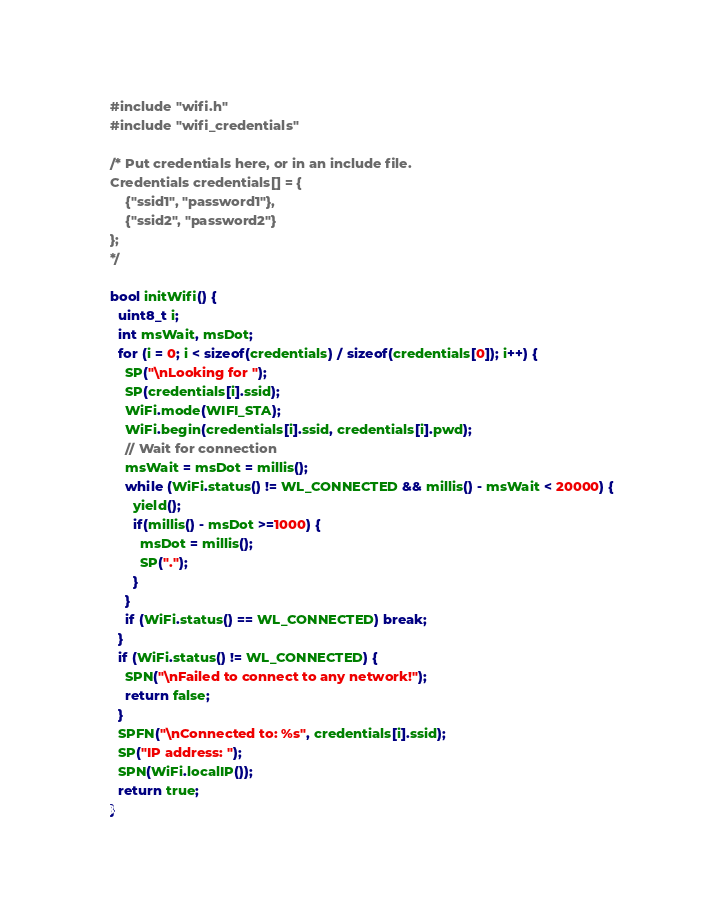<code> <loc_0><loc_0><loc_500><loc_500><_C++_>#include "wifi.h"
#include "wifi_credentials"

/* Put credentials here, or in an include file.
Credentials credentials[] = {
	{"ssid1", "password1"},
	{"ssid2", "password2"}
};
*/

bool initWifi() {
  uint8_t i;
  int msWait, msDot;
  for (i = 0; i < sizeof(credentials) / sizeof(credentials[0]); i++) {
    SP("\nLooking for ");
    SP(credentials[i].ssid);
    WiFi.mode(WIFI_STA);
    WiFi.begin(credentials[i].ssid, credentials[i].pwd);
    // Wait for connection
    msWait = msDot = millis();
    while (WiFi.status() != WL_CONNECTED && millis() - msWait < 20000) {
      yield();
      if(millis() - msDot >=1000) {
        msDot = millis();
        SP(".");
      }
    }
    if (WiFi.status() == WL_CONNECTED) break;
  }
  if (WiFi.status() != WL_CONNECTED) {
    SPN("\nFailed to connect to any network!");
    return false;
  }
  SPFN("\nConnected to: %s", credentials[i].ssid);
  SP("IP address: ");
  SPN(WiFi.localIP());
  return true;
}
</code> 